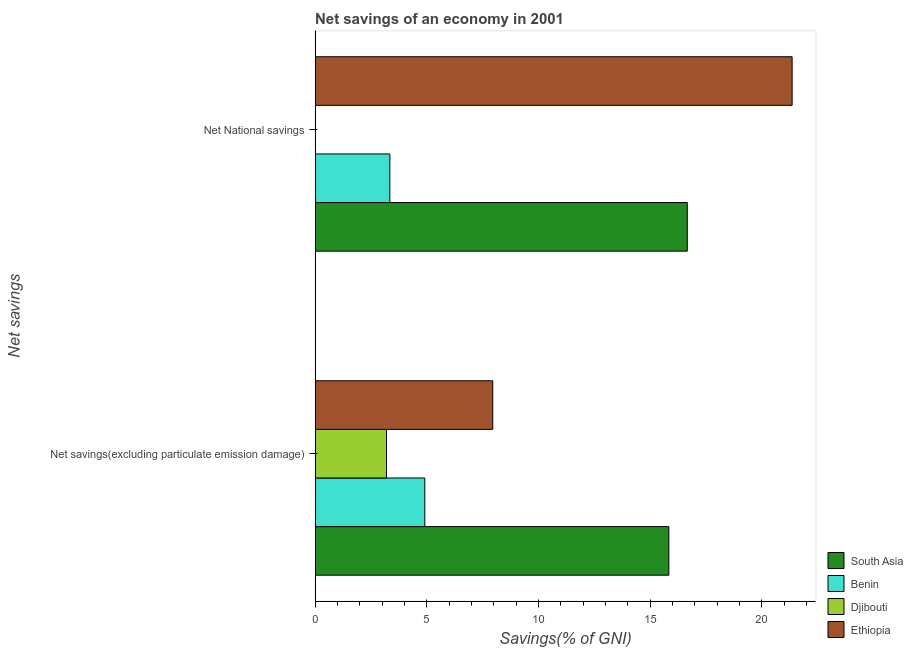How many different coloured bars are there?
Your answer should be compact. 4. Are the number of bars per tick equal to the number of legend labels?
Your answer should be compact. No. Are the number of bars on each tick of the Y-axis equal?
Your answer should be very brief. No. What is the label of the 1st group of bars from the top?
Make the answer very short. Net National savings. What is the net national savings in Benin?
Provide a short and direct response. 3.35. Across all countries, what is the maximum net savings(excluding particulate emission damage)?
Ensure brevity in your answer.  15.84. Across all countries, what is the minimum net savings(excluding particulate emission damage)?
Keep it short and to the point. 3.2. In which country was the net savings(excluding particulate emission damage) maximum?
Your answer should be compact. South Asia. What is the total net national savings in the graph?
Offer a very short reply. 41.36. What is the difference between the net national savings in Benin and that in South Asia?
Your answer should be compact. -13.32. What is the difference between the net savings(excluding particulate emission damage) in South Asia and the net national savings in Ethiopia?
Your response must be concise. -5.52. What is the average net savings(excluding particulate emission damage) per country?
Offer a terse response. 7.97. What is the difference between the net savings(excluding particulate emission damage) and net national savings in Ethiopia?
Give a very brief answer. -13.4. In how many countries, is the net national savings greater than 2 %?
Offer a terse response. 3. What is the ratio of the net savings(excluding particulate emission damage) in South Asia to that in Ethiopia?
Ensure brevity in your answer.  1.99. Is the net national savings in Benin less than that in Ethiopia?
Provide a short and direct response. Yes. How many bars are there?
Keep it short and to the point. 7. Are all the bars in the graph horizontal?
Provide a short and direct response. Yes. How many countries are there in the graph?
Provide a succinct answer. 4. What is the difference between two consecutive major ticks on the X-axis?
Provide a succinct answer. 5. Does the graph contain grids?
Offer a terse response. No. How many legend labels are there?
Ensure brevity in your answer.  4. What is the title of the graph?
Ensure brevity in your answer.  Net savings of an economy in 2001. Does "Sub-Saharan Africa (all income levels)" appear as one of the legend labels in the graph?
Give a very brief answer. No. What is the label or title of the X-axis?
Ensure brevity in your answer.  Savings(% of GNI). What is the label or title of the Y-axis?
Provide a succinct answer. Net savings. What is the Savings(% of GNI) in South Asia in Net savings(excluding particulate emission damage)?
Offer a terse response. 15.84. What is the Savings(% of GNI) of Benin in Net savings(excluding particulate emission damage)?
Your answer should be compact. 4.91. What is the Savings(% of GNI) in Djibouti in Net savings(excluding particulate emission damage)?
Offer a very short reply. 3.2. What is the Savings(% of GNI) of Ethiopia in Net savings(excluding particulate emission damage)?
Offer a terse response. 7.95. What is the Savings(% of GNI) in South Asia in Net National savings?
Offer a very short reply. 16.66. What is the Savings(% of GNI) in Benin in Net National savings?
Ensure brevity in your answer.  3.35. What is the Savings(% of GNI) in Ethiopia in Net National savings?
Keep it short and to the point. 21.36. Across all Net savings, what is the maximum Savings(% of GNI) of South Asia?
Provide a succinct answer. 16.66. Across all Net savings, what is the maximum Savings(% of GNI) in Benin?
Make the answer very short. 4.91. Across all Net savings, what is the maximum Savings(% of GNI) of Djibouti?
Offer a terse response. 3.2. Across all Net savings, what is the maximum Savings(% of GNI) in Ethiopia?
Give a very brief answer. 21.36. Across all Net savings, what is the minimum Savings(% of GNI) in South Asia?
Your answer should be compact. 15.84. Across all Net savings, what is the minimum Savings(% of GNI) in Benin?
Make the answer very short. 3.35. Across all Net savings, what is the minimum Savings(% of GNI) in Ethiopia?
Keep it short and to the point. 7.95. What is the total Savings(% of GNI) in South Asia in the graph?
Provide a succinct answer. 32.5. What is the total Savings(% of GNI) in Benin in the graph?
Offer a terse response. 8.26. What is the total Savings(% of GNI) of Djibouti in the graph?
Give a very brief answer. 3.2. What is the total Savings(% of GNI) in Ethiopia in the graph?
Provide a succinct answer. 29.31. What is the difference between the Savings(% of GNI) of South Asia in Net savings(excluding particulate emission damage) and that in Net National savings?
Provide a short and direct response. -0.83. What is the difference between the Savings(% of GNI) in Benin in Net savings(excluding particulate emission damage) and that in Net National savings?
Your answer should be very brief. 1.56. What is the difference between the Savings(% of GNI) in Ethiopia in Net savings(excluding particulate emission damage) and that in Net National savings?
Your response must be concise. -13.4. What is the difference between the Savings(% of GNI) in South Asia in Net savings(excluding particulate emission damage) and the Savings(% of GNI) in Benin in Net National savings?
Your answer should be very brief. 12.49. What is the difference between the Savings(% of GNI) of South Asia in Net savings(excluding particulate emission damage) and the Savings(% of GNI) of Ethiopia in Net National savings?
Provide a short and direct response. -5.52. What is the difference between the Savings(% of GNI) in Benin in Net savings(excluding particulate emission damage) and the Savings(% of GNI) in Ethiopia in Net National savings?
Provide a succinct answer. -16.45. What is the difference between the Savings(% of GNI) of Djibouti in Net savings(excluding particulate emission damage) and the Savings(% of GNI) of Ethiopia in Net National savings?
Keep it short and to the point. -18.16. What is the average Savings(% of GNI) in South Asia per Net savings?
Give a very brief answer. 16.25. What is the average Savings(% of GNI) in Benin per Net savings?
Your response must be concise. 4.13. What is the average Savings(% of GNI) in Djibouti per Net savings?
Your answer should be compact. 1.6. What is the average Savings(% of GNI) in Ethiopia per Net savings?
Offer a terse response. 14.66. What is the difference between the Savings(% of GNI) of South Asia and Savings(% of GNI) of Benin in Net savings(excluding particulate emission damage)?
Your answer should be compact. 10.93. What is the difference between the Savings(% of GNI) in South Asia and Savings(% of GNI) in Djibouti in Net savings(excluding particulate emission damage)?
Your answer should be compact. 12.64. What is the difference between the Savings(% of GNI) in South Asia and Savings(% of GNI) in Ethiopia in Net savings(excluding particulate emission damage)?
Your answer should be compact. 7.88. What is the difference between the Savings(% of GNI) of Benin and Savings(% of GNI) of Djibouti in Net savings(excluding particulate emission damage)?
Keep it short and to the point. 1.71. What is the difference between the Savings(% of GNI) in Benin and Savings(% of GNI) in Ethiopia in Net savings(excluding particulate emission damage)?
Your response must be concise. -3.04. What is the difference between the Savings(% of GNI) in Djibouti and Savings(% of GNI) in Ethiopia in Net savings(excluding particulate emission damage)?
Make the answer very short. -4.76. What is the difference between the Savings(% of GNI) in South Asia and Savings(% of GNI) in Benin in Net National savings?
Offer a terse response. 13.32. What is the difference between the Savings(% of GNI) in South Asia and Savings(% of GNI) in Ethiopia in Net National savings?
Give a very brief answer. -4.69. What is the difference between the Savings(% of GNI) of Benin and Savings(% of GNI) of Ethiopia in Net National savings?
Provide a short and direct response. -18.01. What is the ratio of the Savings(% of GNI) in South Asia in Net savings(excluding particulate emission damage) to that in Net National savings?
Keep it short and to the point. 0.95. What is the ratio of the Savings(% of GNI) in Benin in Net savings(excluding particulate emission damage) to that in Net National savings?
Ensure brevity in your answer.  1.47. What is the ratio of the Savings(% of GNI) in Ethiopia in Net savings(excluding particulate emission damage) to that in Net National savings?
Offer a terse response. 0.37. What is the difference between the highest and the second highest Savings(% of GNI) of South Asia?
Give a very brief answer. 0.83. What is the difference between the highest and the second highest Savings(% of GNI) of Benin?
Provide a short and direct response. 1.56. What is the difference between the highest and the second highest Savings(% of GNI) in Ethiopia?
Your answer should be very brief. 13.4. What is the difference between the highest and the lowest Savings(% of GNI) of South Asia?
Provide a short and direct response. 0.83. What is the difference between the highest and the lowest Savings(% of GNI) in Benin?
Provide a succinct answer. 1.56. What is the difference between the highest and the lowest Savings(% of GNI) in Djibouti?
Offer a very short reply. 3.2. What is the difference between the highest and the lowest Savings(% of GNI) of Ethiopia?
Offer a very short reply. 13.4. 